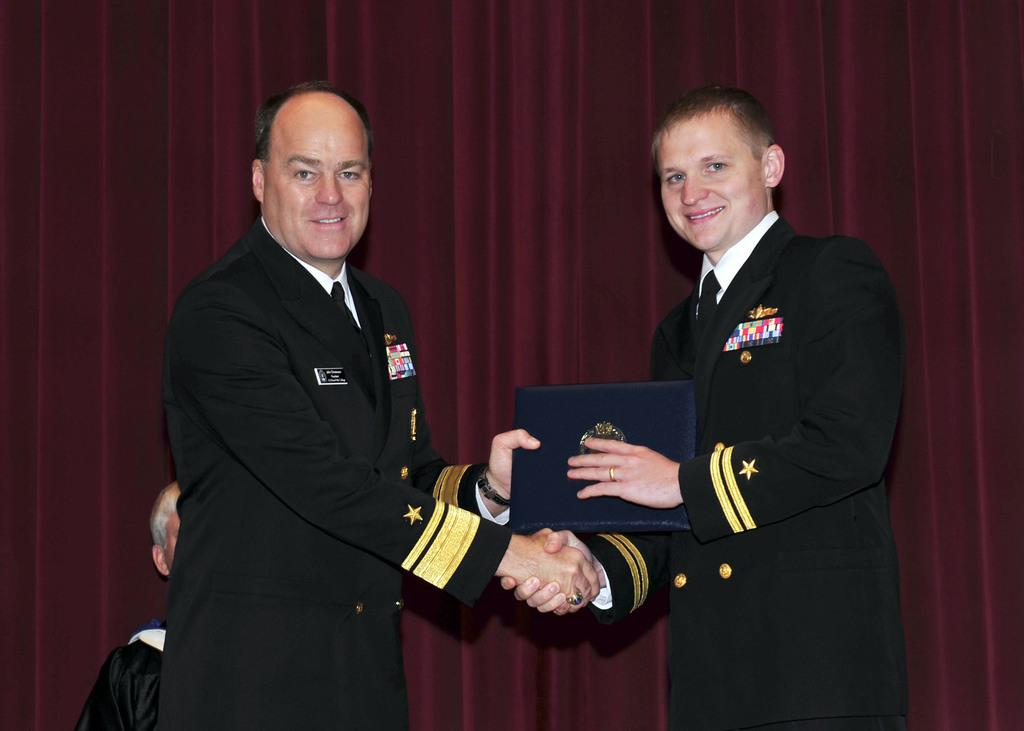How many people are in the image? There are two persons in the image. What are the persons wearing? Both persons are wearing coats and ties. What is one person holding in the image? One person is holding a file with an emblem on it. Can you describe the background of the image? There is a person in the background of the image, and there is a curtain present. What type of hammer can be seen in the image? There is no hammer present in the image. Are the two persons in the image having an argument? There is no indication of an argument between the two persons in the image. 